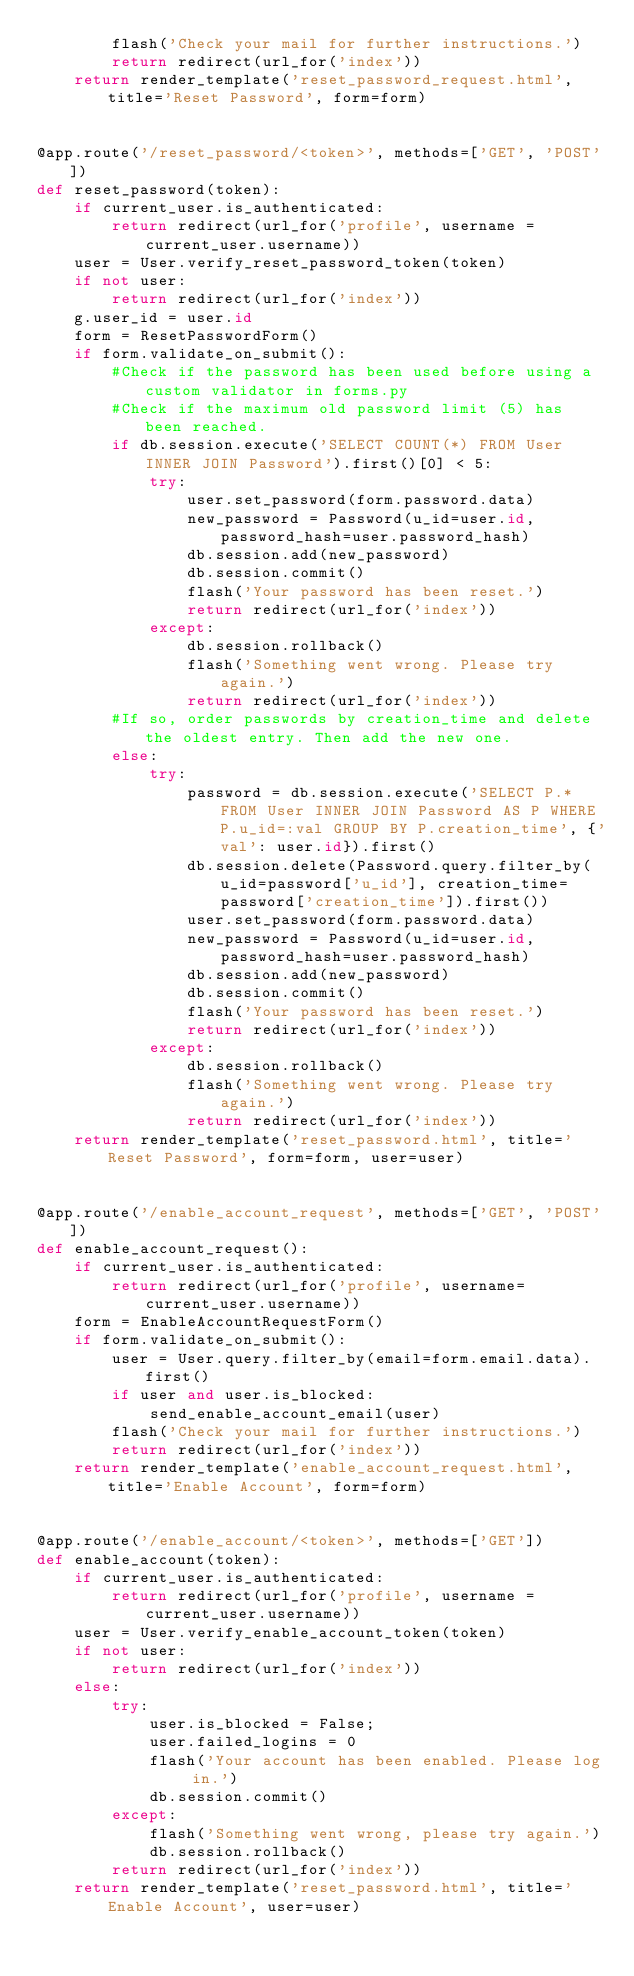Convert code to text. <code><loc_0><loc_0><loc_500><loc_500><_Python_>        flash('Check your mail for further instructions.')
        return redirect(url_for('index'))
    return render_template('reset_password_request.html', title='Reset Password', form=form)


@app.route('/reset_password/<token>', methods=['GET', 'POST'])
def reset_password(token):
    if current_user.is_authenticated:
        return redirect(url_for('profile', username = current_user.username))
    user = User.verify_reset_password_token(token)
    if not user:
        return redirect(url_for('index'))
    g.user_id = user.id
    form = ResetPasswordForm()
    if form.validate_on_submit():
        #Check if the password has been used before using a custom validator in forms.py
        #Check if the maximum old password limit (5) has been reached.                  
        if db.session.execute('SELECT COUNT(*) FROM User INNER JOIN Password').first()[0] < 5:
            try:
                user.set_password(form.password.data)
                new_password = Password(u_id=user.id, password_hash=user.password_hash)
                db.session.add(new_password)
                db.session.commit()
                flash('Your password has been reset.')
                return redirect(url_for('index'))
            except:
                db.session.rollback()
                flash('Something went wrong. Please try again.')
                return redirect(url_for('index'))
        #If so, order passwords by creation_time and delete the oldest entry. Then add the new one.
        else:
            try:
                password = db.session.execute('SELECT P.* FROM User INNER JOIN Password AS P WHERE P.u_id=:val GROUP BY P.creation_time', {'val': user.id}).first()
                db.session.delete(Password.query.filter_by(u_id=password['u_id'], creation_time=password['creation_time']).first())
                user.set_password(form.password.data)
                new_password = Password(u_id=user.id, password_hash=user.password_hash)
                db.session.add(new_password)
                db.session.commit()
                flash('Your password has been reset.')
                return redirect(url_for('index'))
            except:
                db.session.rollback()
                flash('Something went wrong. Please try again.')
                return redirect(url_for('index'))
    return render_template('reset_password.html', title='Reset Password', form=form, user=user)        


@app.route('/enable_account_request', methods=['GET', 'POST'])
def enable_account_request():
    if current_user.is_authenticated:
        return redirect(url_for('profile', username=current_user.username))
    form = EnableAccountRequestForm()
    if form.validate_on_submit():
        user = User.query.filter_by(email=form.email.data).first()
        if user and user.is_blocked:
            send_enable_account_email(user)
        flash('Check your mail for further instructions.')
        return redirect(url_for('index'))
    return render_template('enable_account_request.html', title='Enable Account', form=form)


@app.route('/enable_account/<token>', methods=['GET'])
def enable_account(token):
    if current_user.is_authenticated:
        return redirect(url_for('profile', username = current_user.username))
    user = User.verify_enable_account_token(token)
    if not user:
        return redirect(url_for('index'))
    else:
        try:
            user.is_blocked = False;
            user.failed_logins = 0
            flash('Your account has been enabled. Please log in.')
            db.session.commit()
        except:
            flash('Something went wrong, please try again.')
            db.session.rollback()
        return redirect(url_for('index'))
    return render_template('reset_password.html', title='Enable Account', user=user)
</code> 